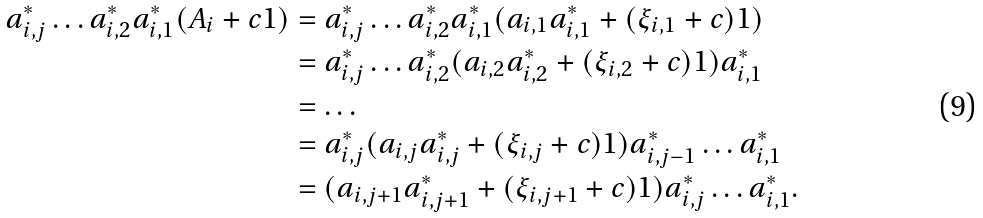<formula> <loc_0><loc_0><loc_500><loc_500>a ^ { * } _ { i , j } \dots a ^ { * } _ { i , 2 } a ^ { * } _ { i , 1 } ( A _ { i } + c 1 ) & = a ^ { * } _ { i , j } \dots a ^ { * } _ { i , 2 } a ^ { * } _ { i , 1 } ( a _ { i , 1 } a ^ { * } _ { i , 1 } + ( \xi _ { i , 1 } + c ) 1 ) \\ & = a ^ { * } _ { i , j } \dots a ^ { * } _ { i , 2 } ( a _ { i , 2 } a ^ { * } _ { i , 2 } + ( \xi _ { i , 2 } + c ) 1 ) a ^ { * } _ { i , 1 } \\ & = \dots \\ & = a ^ { * } _ { i , j } ( a _ { i , j } a ^ { * } _ { i , j } + ( \xi _ { i , j } + c ) 1 ) a ^ { * } _ { i , j - 1 } \dots a ^ { * } _ { i , 1 } \\ & = ( a _ { i , j + 1 } a ^ { * } _ { i , j + 1 } + ( \xi _ { i , j + 1 } + c ) 1 ) a ^ { * } _ { i , j } \dots a ^ { * } _ { i , 1 } .</formula> 